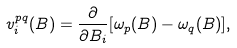<formula> <loc_0><loc_0><loc_500><loc_500>v _ { i } ^ { p q } ( B ) = \frac { \partial } { \partial B _ { i } } [ \omega _ { p } ( B ) - \omega _ { q } ( B ) ] ,</formula> 